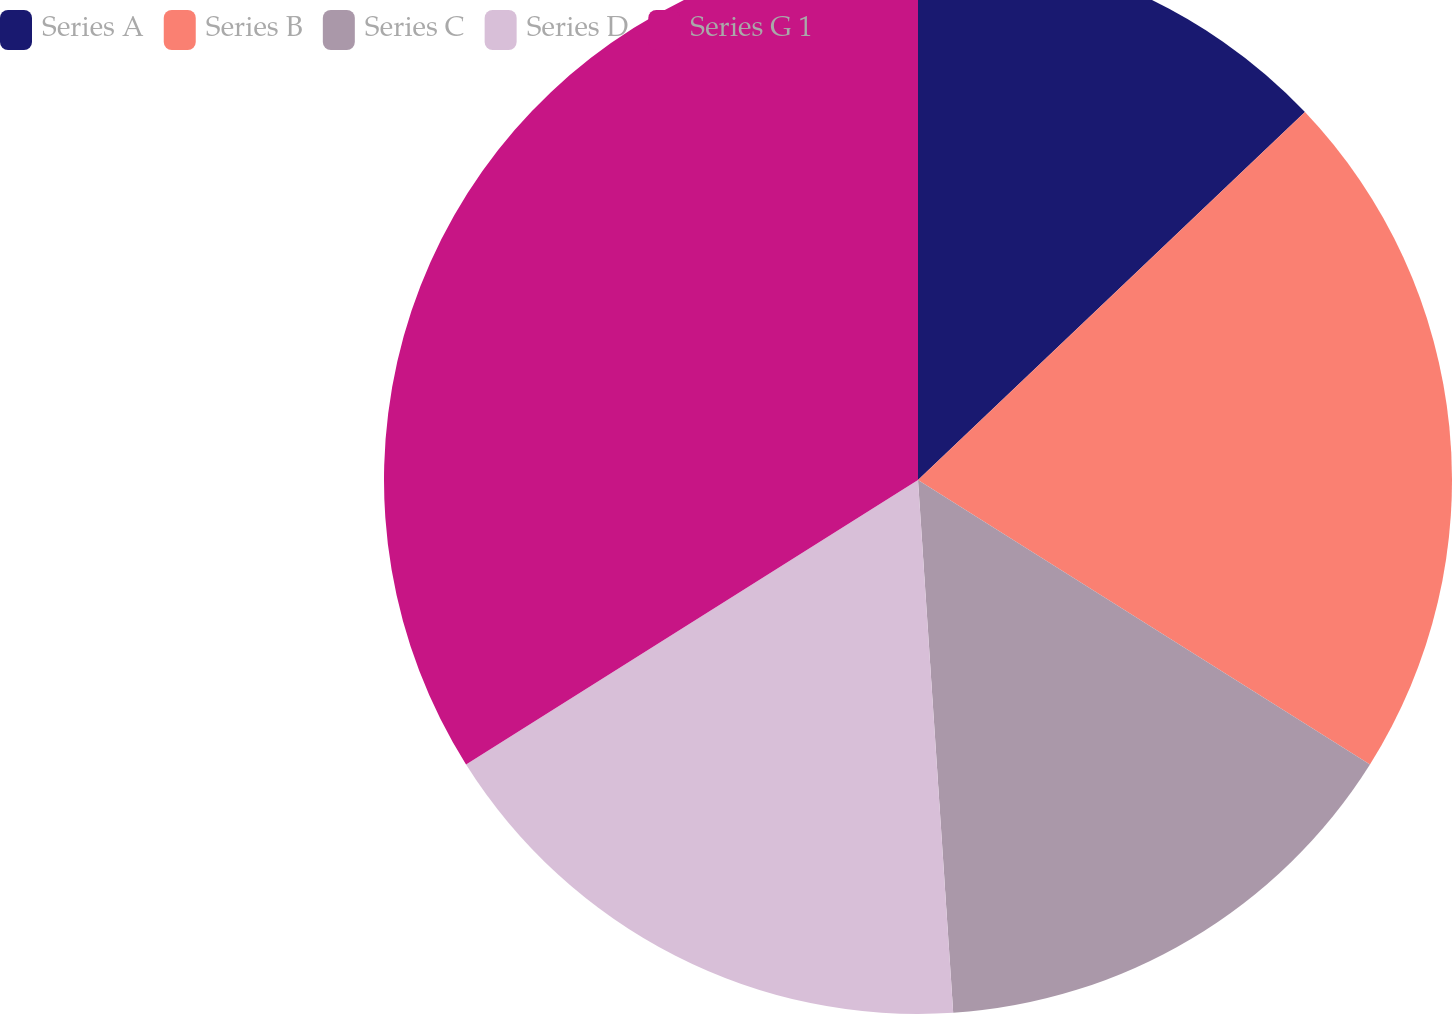Convert chart to OTSL. <chart><loc_0><loc_0><loc_500><loc_500><pie_chart><fcel>Series A<fcel>Series B<fcel>Series C<fcel>Series D<fcel>Series G 1<nl><fcel>12.9%<fcel>21.04%<fcel>15.01%<fcel>17.11%<fcel>33.94%<nl></chart> 